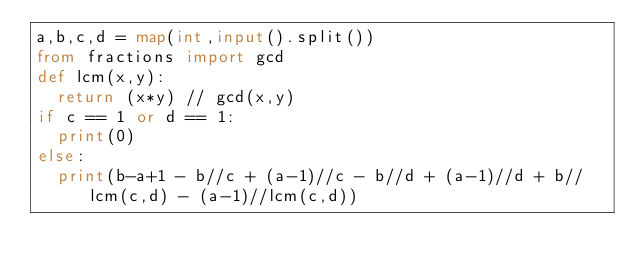<code> <loc_0><loc_0><loc_500><loc_500><_Python_>a,b,c,d = map(int,input().split())
from fractions import gcd
def lcm(x,y):
  return (x*y) // gcd(x,y)
if c == 1 or d == 1:
  print(0)
else:
  print(b-a+1 - b//c + (a-1)//c - b//d + (a-1)//d + b//lcm(c,d) - (a-1)//lcm(c,d))</code> 